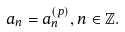Convert formula to latex. <formula><loc_0><loc_0><loc_500><loc_500>a _ { n } = a _ { n } ^ { ( p ) } , n \in \mathbb { Z } .</formula> 